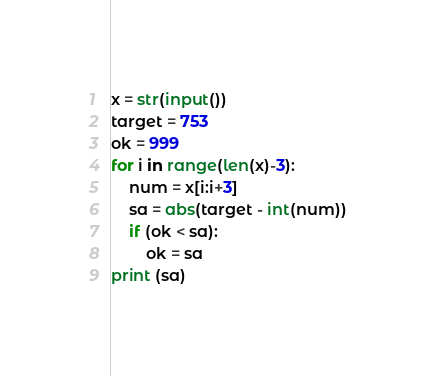Convert code to text. <code><loc_0><loc_0><loc_500><loc_500><_Python_>x = str(input())
target = 753
ok = 999
for i in range(len(x)-3):
	num = x[i:i+3]
	sa = abs(target - int(num))
	if (ok < sa):
		ok = sa
print (sa)</code> 